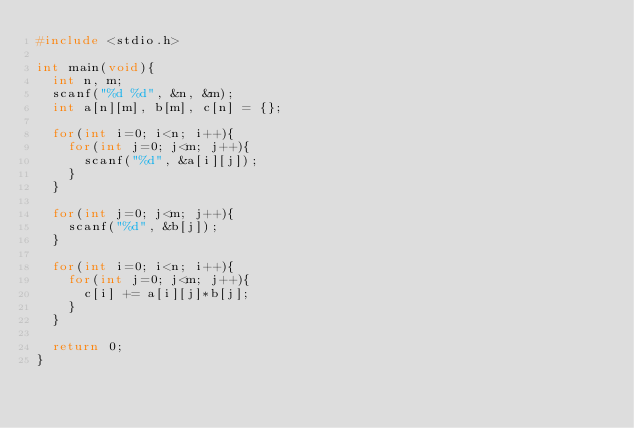<code> <loc_0><loc_0><loc_500><loc_500><_C_>#include <stdio.h>

int main(void){
  int n, m;
  scanf("%d %d", &n, &m);
  int a[n][m], b[m], c[n] = {};

  for(int i=0; i<n; i++){
    for(int j=0; j<m; j++){
      scanf("%d", &a[i][j]);
    }
  }

  for(int j=0; j<m; j++){
    scanf("%d", &b[j]);
  }

  for(int i=0; i<n; i++){
    for(int j=0; j<m; j++){
      c[i] += a[i][j]*b[j];
    }
  }

  return 0;
}

</code> 